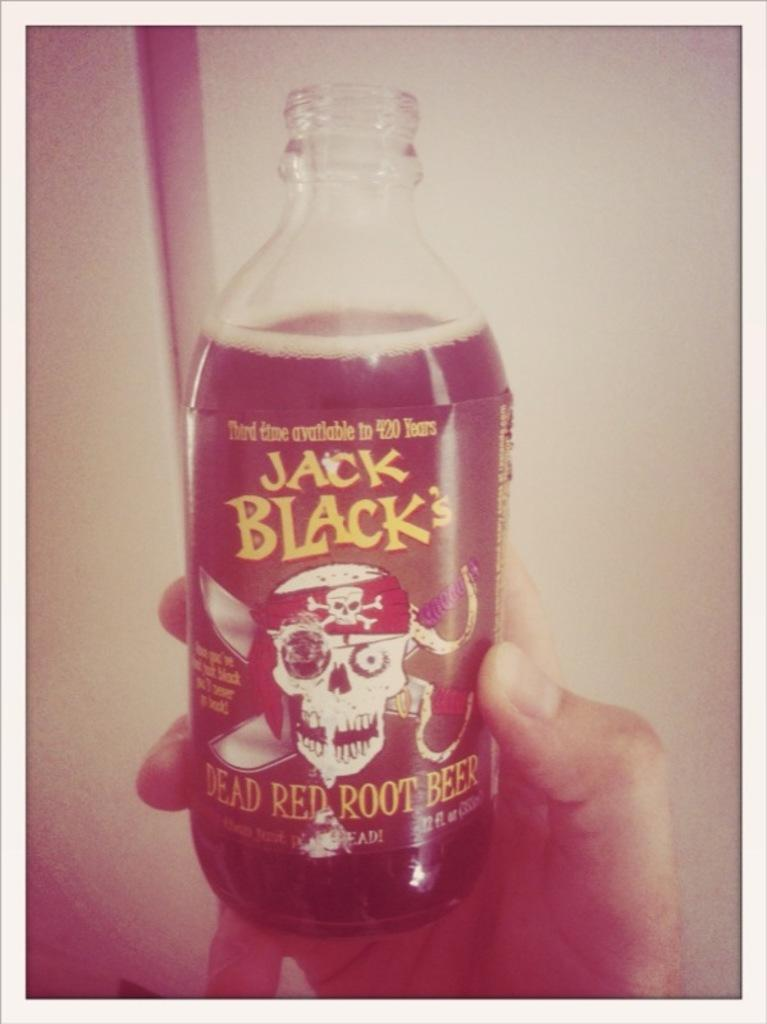What is present in the image? There is a person in the image. What is the person holding in the image? The person is holding a glass bottle. Is there a cobweb visible in the image? There is no mention of a cobweb in the provided facts, so we cannot determine if one is present in the image. 